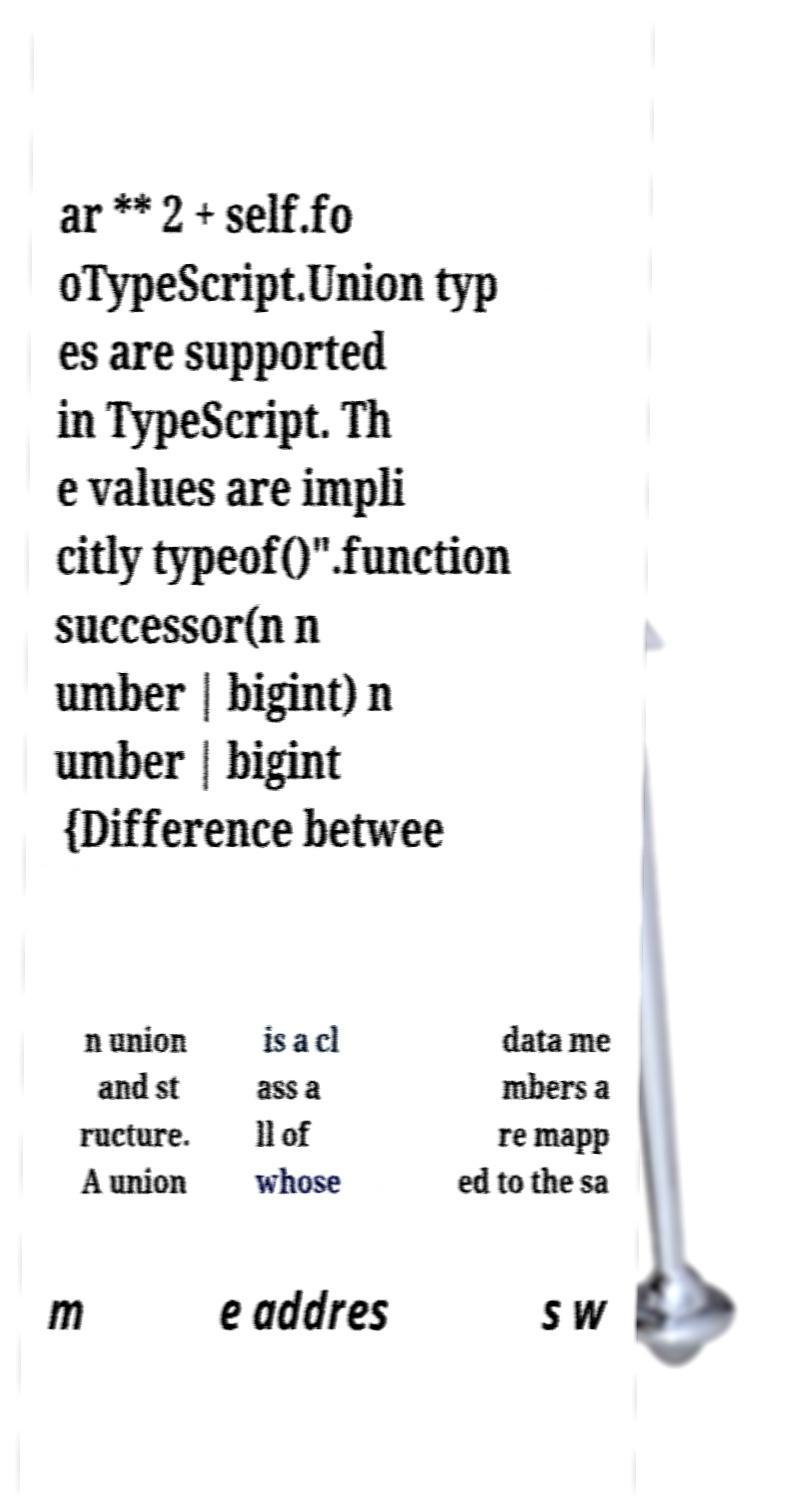Please read and relay the text visible in this image. What does it say? ar ** 2 + self.fo oTypeScript.Union typ es are supported in TypeScript. Th e values are impli citly typeof()".function successor(n n umber | bigint) n umber | bigint {Difference betwee n union and st ructure. A union is a cl ass a ll of whose data me mbers a re mapp ed to the sa m e addres s w 